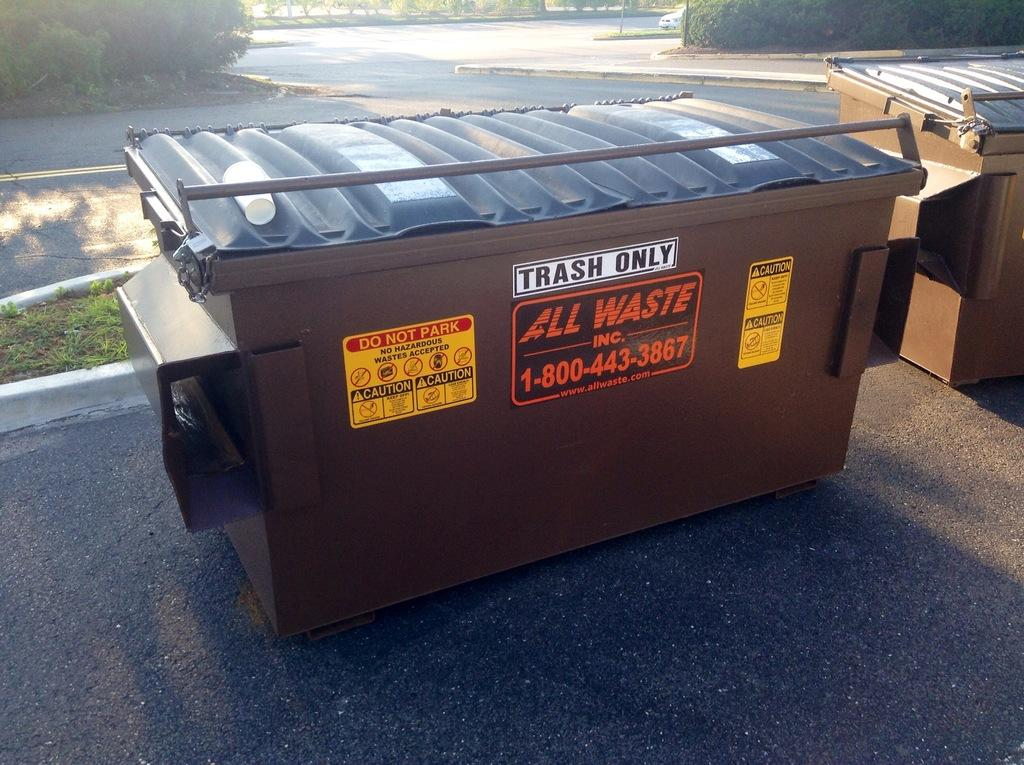<image>
Offer a succinct explanation of the picture presented. A brown dumpster from All Waste Inc. has a sign telling people that they can only put trash into it. 